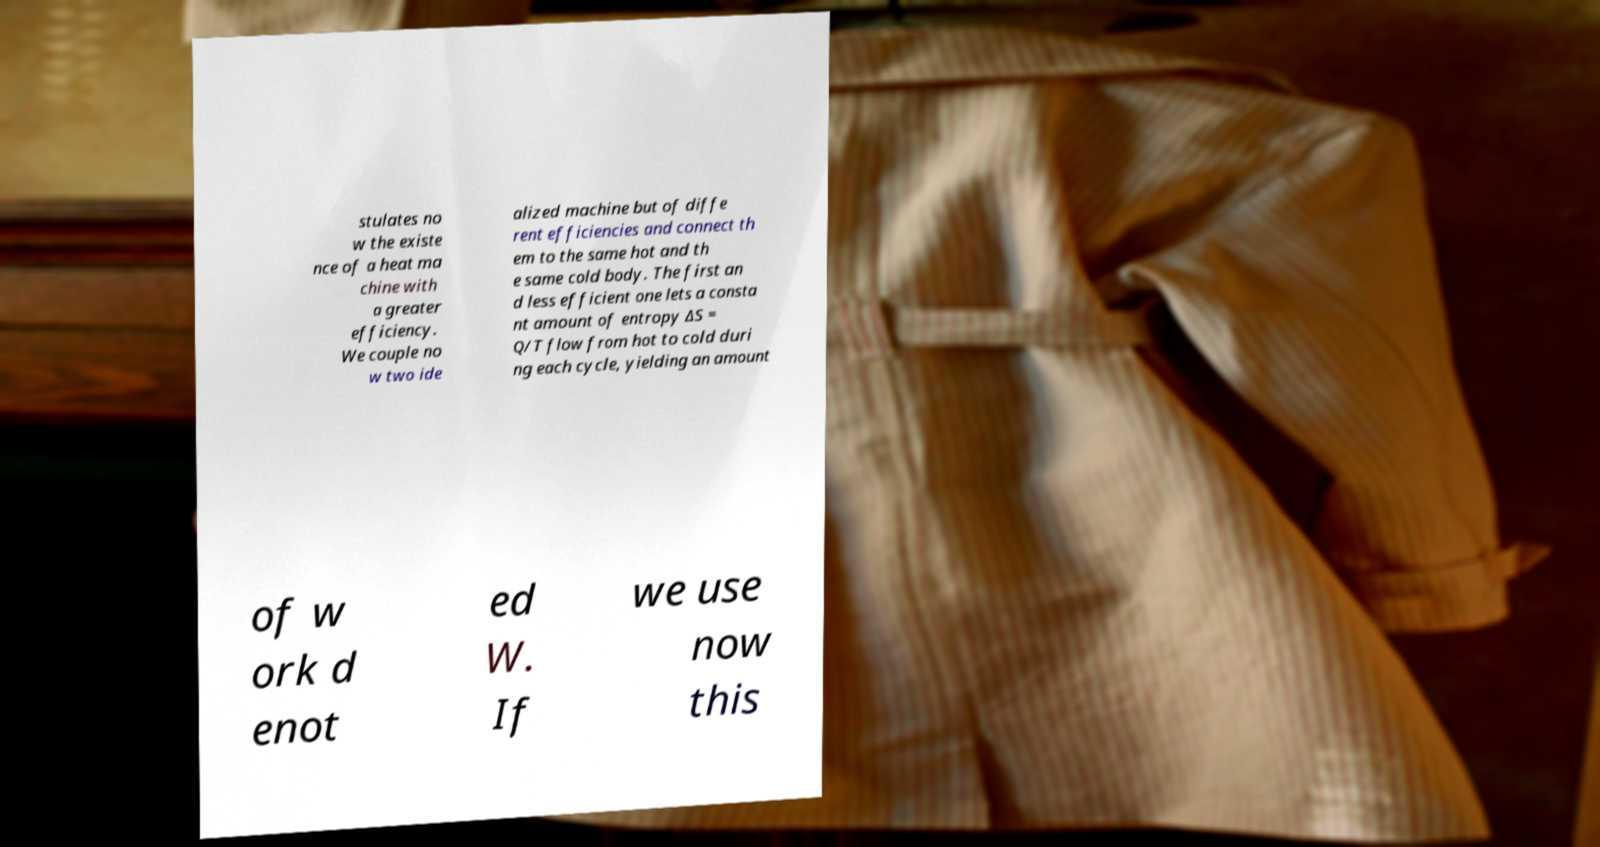Can you accurately transcribe the text from the provided image for me? stulates no w the existe nce of a heat ma chine with a greater efficiency. We couple no w two ide alized machine but of diffe rent efficiencies and connect th em to the same hot and th e same cold body. The first an d less efficient one lets a consta nt amount of entropy ∆S = Q/T flow from hot to cold duri ng each cycle, yielding an amount of w ork d enot ed W. If we use now this 